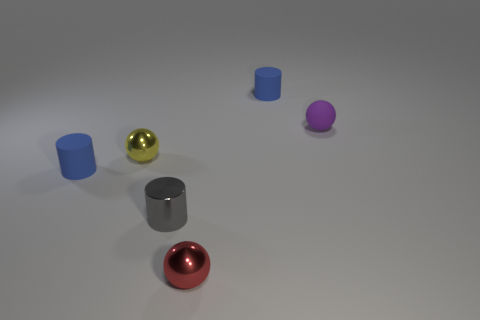What could be the implied use or purpose of each object in the scene? Each object's simplistic shape, such as cylinders and spheres, hints at a potential teaching tool or a part of a visual art installation. Their basic forms could be used to illustrate concepts of geometry or spatial design. 